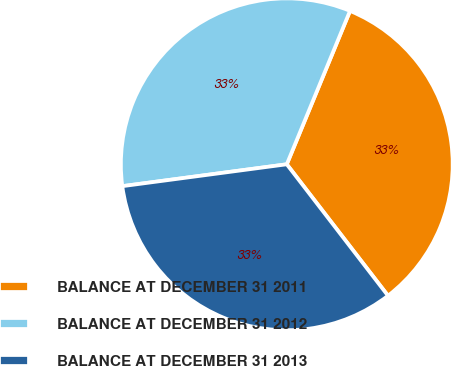Convert chart to OTSL. <chart><loc_0><loc_0><loc_500><loc_500><pie_chart><fcel>BALANCE AT DECEMBER 31 2011<fcel>BALANCE AT DECEMBER 31 2012<fcel>BALANCE AT DECEMBER 31 2013<nl><fcel>33.33%<fcel>33.33%<fcel>33.34%<nl></chart> 